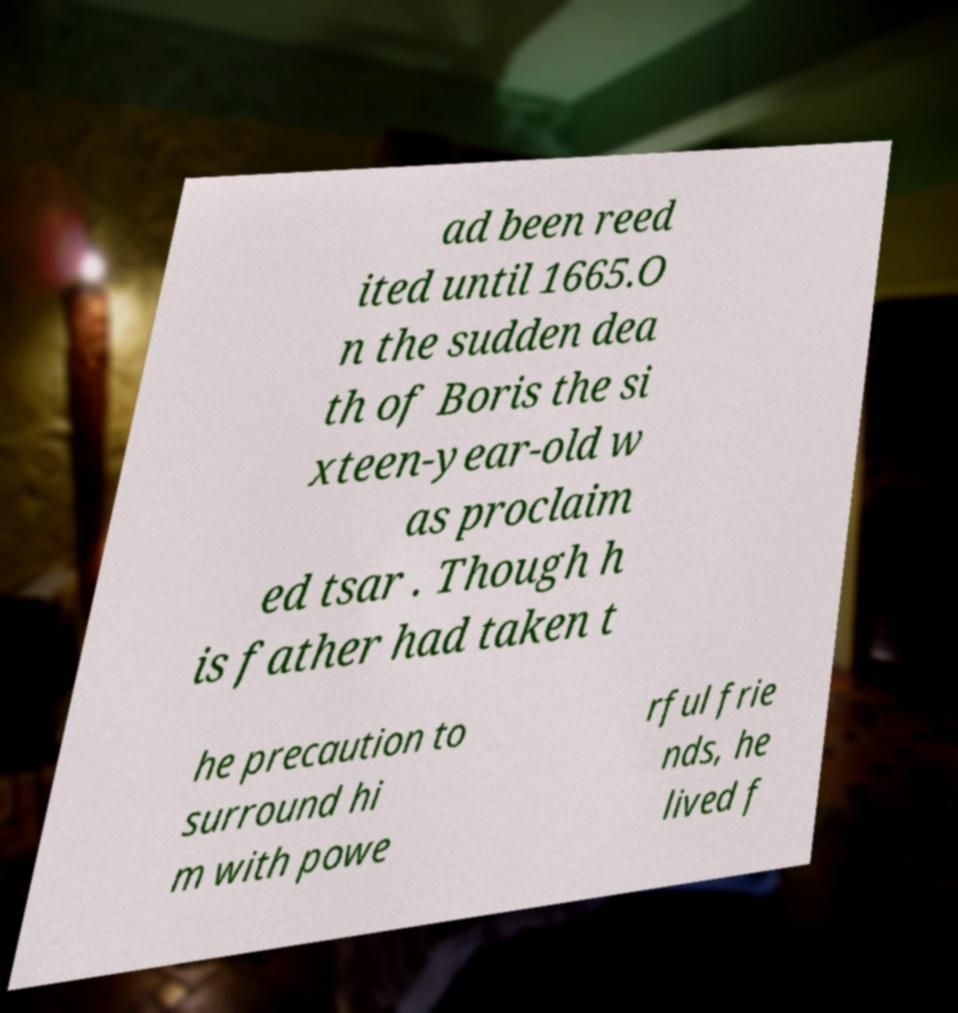Can you read and provide the text displayed in the image?This photo seems to have some interesting text. Can you extract and type it out for me? ad been reed ited until 1665.O n the sudden dea th of Boris the si xteen-year-old w as proclaim ed tsar . Though h is father had taken t he precaution to surround hi m with powe rful frie nds, he lived f 